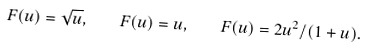Convert formula to latex. <formula><loc_0><loc_0><loc_500><loc_500>F ( u ) = \sqrt { u } , \quad F ( u ) = u , \quad F ( u ) = 2 u ^ { 2 } / ( 1 + u ) .</formula> 